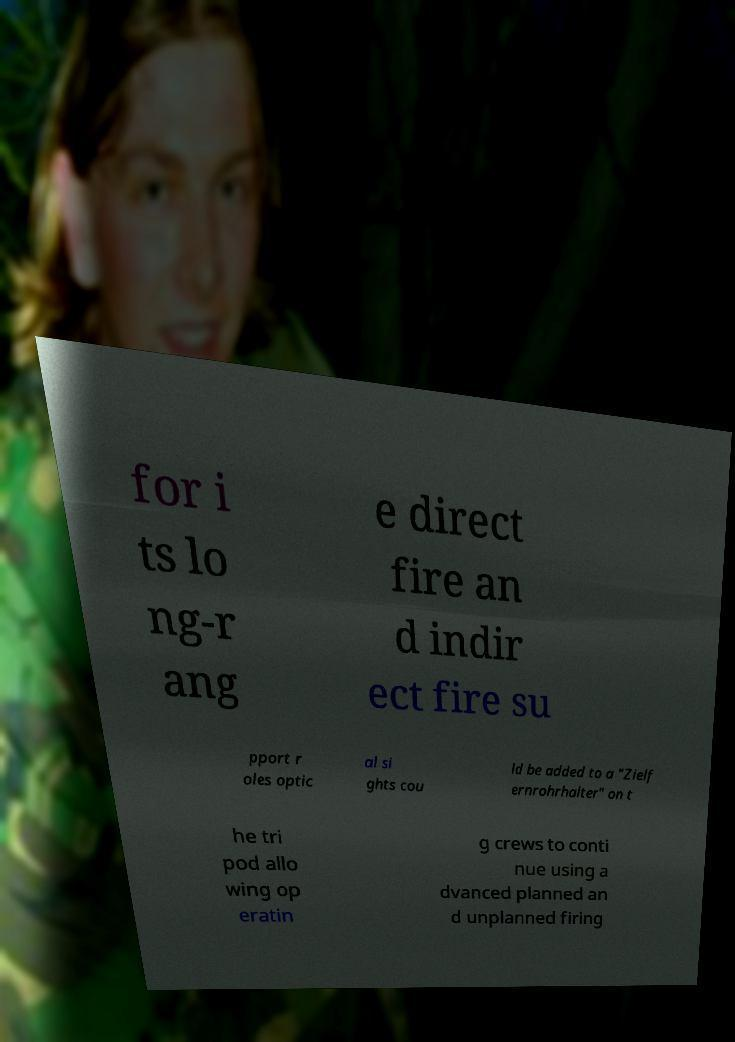What messages or text are displayed in this image? I need them in a readable, typed format. for i ts lo ng-r ang e direct fire an d indir ect fire su pport r oles optic al si ghts cou ld be added to a "Zielf ernrohrhalter" on t he tri pod allo wing op eratin g crews to conti nue using a dvanced planned an d unplanned firing 